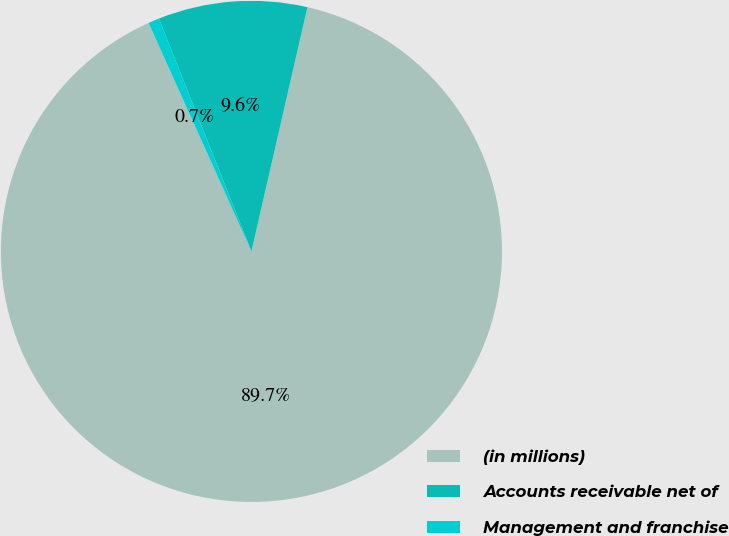Convert chart to OTSL. <chart><loc_0><loc_0><loc_500><loc_500><pie_chart><fcel>(in millions)<fcel>Accounts receivable net of<fcel>Management and franchise<nl><fcel>89.68%<fcel>9.61%<fcel>0.71%<nl></chart> 